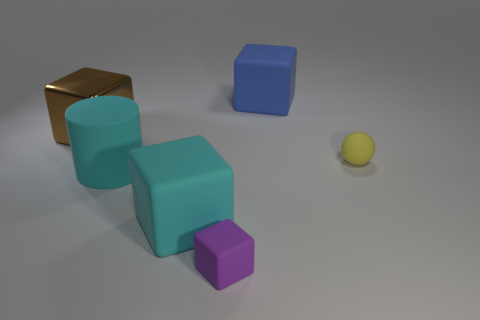Subtract all tiny purple rubber cubes. How many cubes are left? 3 Subtract all blue cubes. How many cubes are left? 3 Add 2 yellow rubber objects. How many objects exist? 8 Subtract all balls. How many objects are left? 5 Subtract 2 blocks. How many blocks are left? 2 Subtract all cyan cubes. Subtract all purple cylinders. How many cubes are left? 3 Subtract all small green metallic cylinders. Subtract all cyan cubes. How many objects are left? 5 Add 1 yellow rubber things. How many yellow rubber things are left? 2 Add 4 big gray things. How many big gray things exist? 4 Subtract 0 green spheres. How many objects are left? 6 